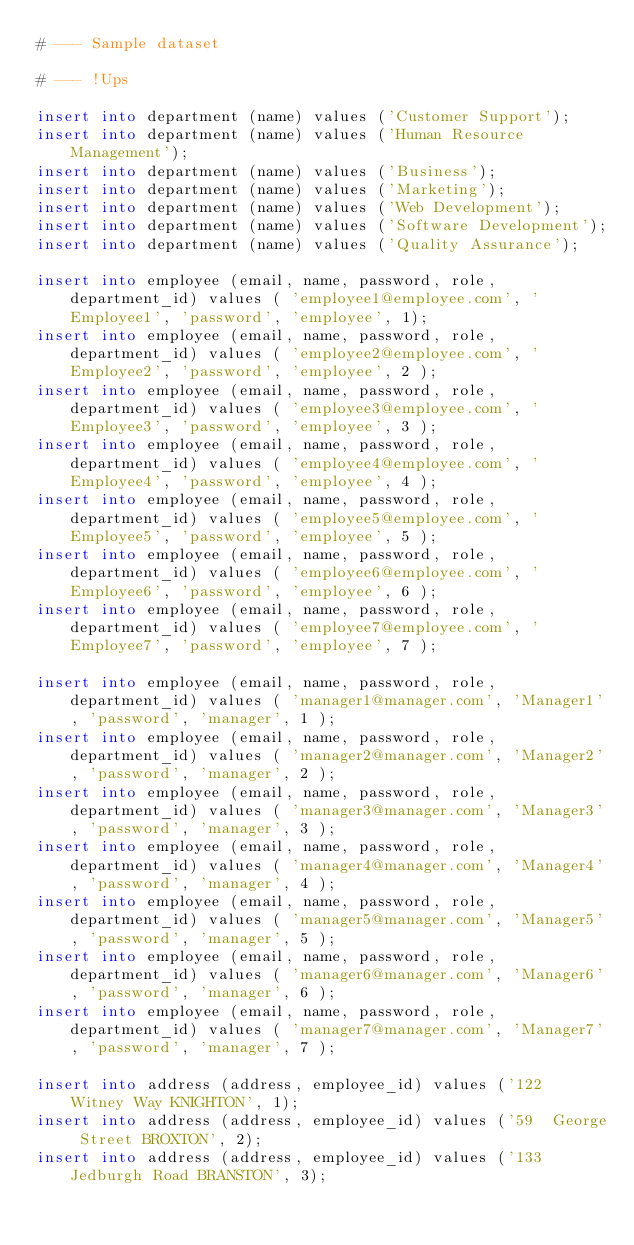Convert code to text. <code><loc_0><loc_0><loc_500><loc_500><_SQL_># --- Sample dataset

# --- !Ups

insert into department (name) values ('Customer Support');
insert into department (name) values ('Human Resource Management');
insert into department (name) values ('Business');
insert into department (name) values ('Marketing');
insert into department (name) values ('Web Development');
insert into department (name) values ('Software Development');
insert into department (name) values ('Quality Assurance');

insert into employee (email, name, password, role, department_id) values ( 'employee1@employee.com', 'Employee1', 'password', 'employee', 1);
insert into employee (email, name, password, role, department_id) values ( 'employee2@employee.com', 'Employee2', 'password', 'employee', 2 );
insert into employee (email, name, password, role, department_id) values ( 'employee3@employee.com', 'Employee3', 'password', 'employee', 3 );
insert into employee (email, name, password, role, department_id) values ( 'employee4@employee.com', 'Employee4', 'password', 'employee', 4 );
insert into employee (email, name, password, role, department_id) values ( 'employee5@employee.com', 'Employee5', 'password', 'employee', 5 );
insert into employee (email, name, password, role, department_id) values ( 'employee6@employee.com', 'Employee6', 'password', 'employee', 6 );
insert into employee (email, name, password, role, department_id) values ( 'employee7@employee.com', 'Employee7', 'password', 'employee', 7 );

insert into employee (email, name, password, role, department_id) values ( 'manager1@manager.com', 'Manager1', 'password', 'manager', 1 );
insert into employee (email, name, password, role, department_id) values ( 'manager2@manager.com', 'Manager2', 'password', 'manager', 2 );
insert into employee (email, name, password, role, department_id) values ( 'manager3@manager.com', 'Manager3', 'password', 'manager', 3 );
insert into employee (email, name, password, role, department_id) values ( 'manager4@manager.com', 'Manager4', 'password', 'manager', 4 );
insert into employee (email, name, password, role, department_id) values ( 'manager5@manager.com', 'Manager5', 'password', 'manager', 5 );
insert into employee (email, name, password, role, department_id) values ( 'manager6@manager.com', 'Manager6', 'password', 'manager', 6 );
insert into employee (email, name, password, role, department_id) values ( 'manager7@manager.com', 'Manager7', 'password', 'manager', 7 );

insert into address (address, employee_id) values ('122  Witney Way KNIGHTON', 1);
insert into address (address, employee_id) values ('59  George Street BROXTON', 2);
insert into address (address, employee_id) values ('133  Jedburgh Road BRANSTON', 3);</code> 